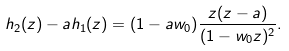Convert formula to latex. <formula><loc_0><loc_0><loc_500><loc_500>h _ { 2 } ( z ) - a h _ { 1 } ( z ) = ( 1 - a w _ { 0 } ) \frac { z ( z - a ) } { ( 1 - w _ { 0 } z ) ^ { 2 } } .</formula> 